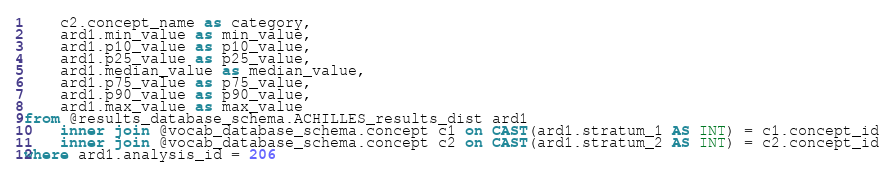<code> <loc_0><loc_0><loc_500><loc_500><_SQL_>	c2.concept_name as category,
	ard1.min_value as min_value,
	ard1.p10_value as p10_value,
	ard1.p25_value as p25_value,
	ard1.median_value as median_value,
	ard1.p75_value as p75_value,
	ard1.p90_value as p90_value,
	ard1.max_value as max_value
from @results_database_schema.ACHILLES_results_dist ard1
	inner join @vocab_database_schema.concept c1 on CAST(ard1.stratum_1 AS INT) = c1.concept_id
	inner join @vocab_database_schema.concept c2 on CAST(ard1.stratum_2 AS INT) = c2.concept_id
where ard1.analysis_id = 206
</code> 